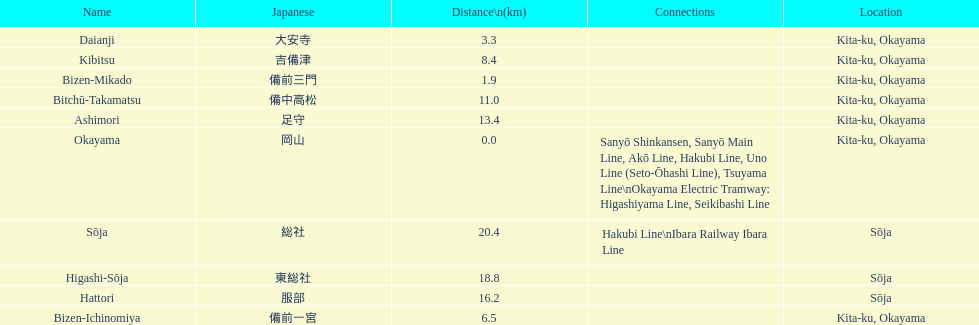Which has the most distance, hattori or kibitsu? Hattori. 